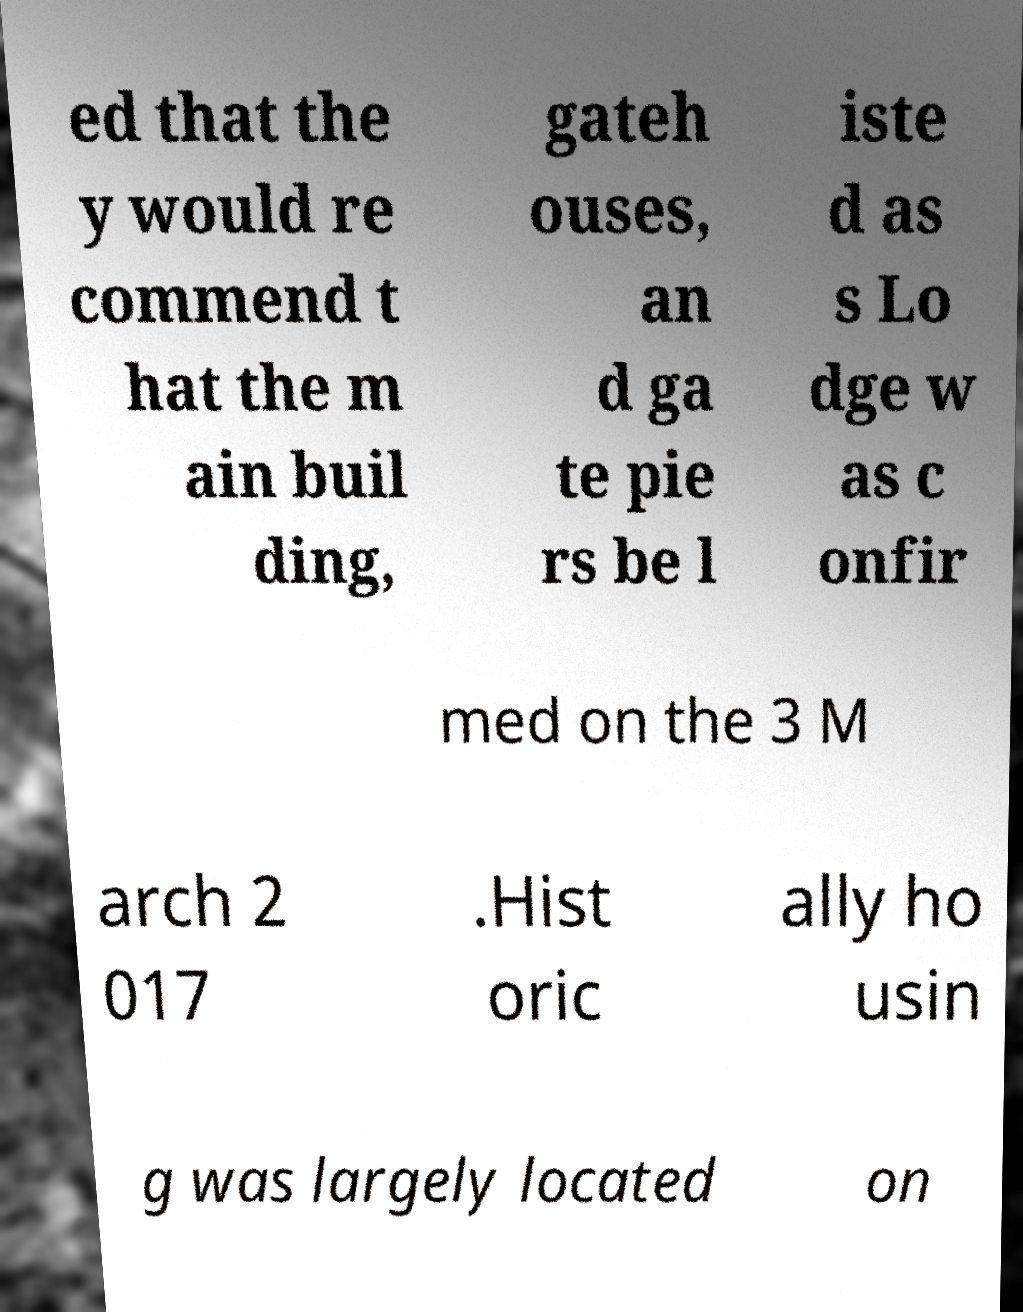For documentation purposes, I need the text within this image transcribed. Could you provide that? ed that the y would re commend t hat the m ain buil ding, gateh ouses, an d ga te pie rs be l iste d as s Lo dge w as c onfir med on the 3 M arch 2 017 .Hist oric ally ho usin g was largely located on 